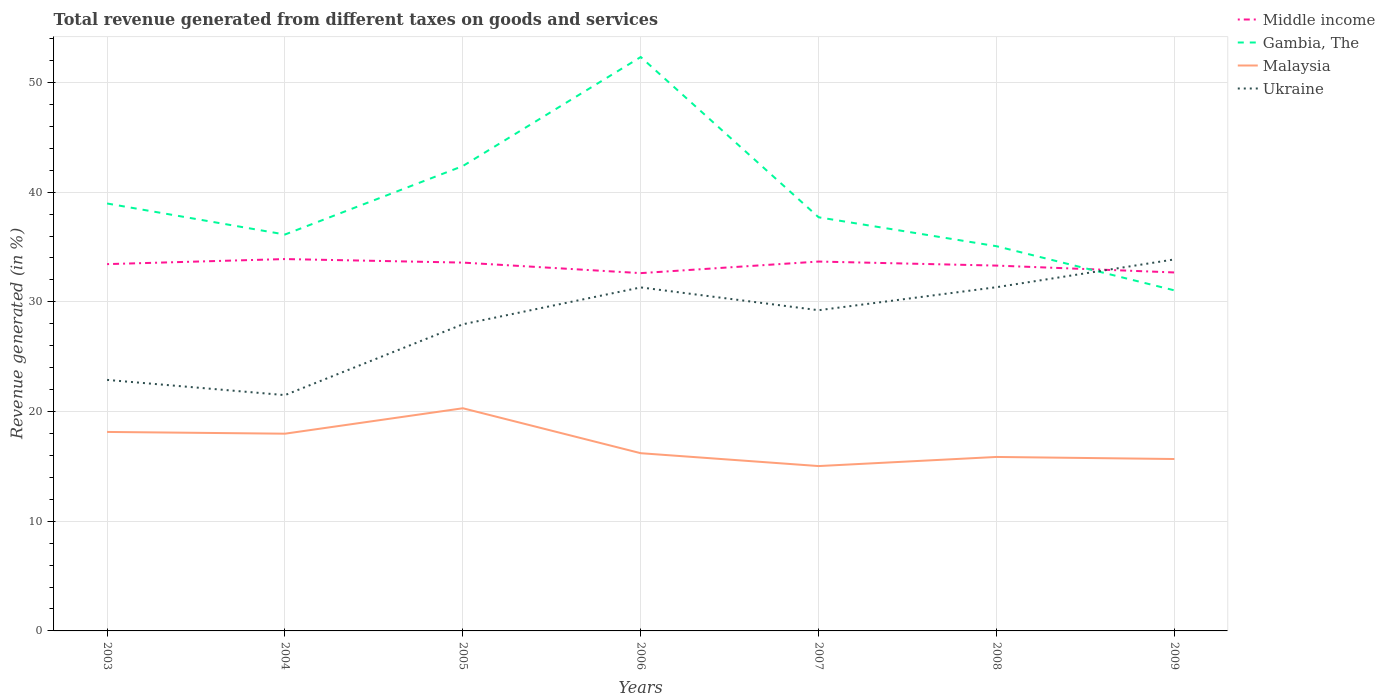Is the number of lines equal to the number of legend labels?
Make the answer very short. Yes. Across all years, what is the maximum total revenue generated in Ukraine?
Your response must be concise. 21.5. What is the total total revenue generated in Malaysia in the graph?
Provide a succinct answer. 2.12. What is the difference between the highest and the second highest total revenue generated in Middle income?
Offer a terse response. 1.28. What is the difference between the highest and the lowest total revenue generated in Malaysia?
Your answer should be compact. 3. Is the total revenue generated in Malaysia strictly greater than the total revenue generated in Middle income over the years?
Provide a succinct answer. Yes. What is the difference between two consecutive major ticks on the Y-axis?
Provide a short and direct response. 10. Are the values on the major ticks of Y-axis written in scientific E-notation?
Your answer should be very brief. No. Does the graph contain grids?
Provide a short and direct response. Yes. Where does the legend appear in the graph?
Provide a succinct answer. Top right. How many legend labels are there?
Provide a succinct answer. 4. What is the title of the graph?
Keep it short and to the point. Total revenue generated from different taxes on goods and services. Does "Iran" appear as one of the legend labels in the graph?
Provide a succinct answer. No. What is the label or title of the X-axis?
Your answer should be compact. Years. What is the label or title of the Y-axis?
Your answer should be compact. Revenue generated (in %). What is the Revenue generated (in %) in Middle income in 2003?
Make the answer very short. 33.44. What is the Revenue generated (in %) in Gambia, The in 2003?
Offer a terse response. 38.97. What is the Revenue generated (in %) in Malaysia in 2003?
Keep it short and to the point. 18.14. What is the Revenue generated (in %) in Ukraine in 2003?
Provide a succinct answer. 22.89. What is the Revenue generated (in %) in Middle income in 2004?
Give a very brief answer. 33.9. What is the Revenue generated (in %) in Gambia, The in 2004?
Your answer should be compact. 36.14. What is the Revenue generated (in %) of Malaysia in 2004?
Your answer should be compact. 17.98. What is the Revenue generated (in %) of Ukraine in 2004?
Your answer should be compact. 21.5. What is the Revenue generated (in %) of Middle income in 2005?
Your answer should be compact. 33.58. What is the Revenue generated (in %) of Gambia, The in 2005?
Your answer should be compact. 42.38. What is the Revenue generated (in %) in Malaysia in 2005?
Ensure brevity in your answer.  20.3. What is the Revenue generated (in %) of Ukraine in 2005?
Provide a short and direct response. 27.96. What is the Revenue generated (in %) in Middle income in 2006?
Keep it short and to the point. 32.62. What is the Revenue generated (in %) in Gambia, The in 2006?
Provide a short and direct response. 52.32. What is the Revenue generated (in %) of Malaysia in 2006?
Your answer should be very brief. 16.2. What is the Revenue generated (in %) of Ukraine in 2006?
Keep it short and to the point. 31.32. What is the Revenue generated (in %) of Middle income in 2007?
Your answer should be very brief. 33.68. What is the Revenue generated (in %) in Gambia, The in 2007?
Provide a succinct answer. 37.71. What is the Revenue generated (in %) in Malaysia in 2007?
Give a very brief answer. 15.03. What is the Revenue generated (in %) in Ukraine in 2007?
Make the answer very short. 29.24. What is the Revenue generated (in %) in Middle income in 2008?
Your response must be concise. 33.31. What is the Revenue generated (in %) in Gambia, The in 2008?
Provide a short and direct response. 35.07. What is the Revenue generated (in %) of Malaysia in 2008?
Ensure brevity in your answer.  15.86. What is the Revenue generated (in %) in Ukraine in 2008?
Ensure brevity in your answer.  31.34. What is the Revenue generated (in %) of Middle income in 2009?
Your answer should be compact. 32.68. What is the Revenue generated (in %) of Gambia, The in 2009?
Offer a very short reply. 31.05. What is the Revenue generated (in %) in Malaysia in 2009?
Your answer should be very brief. 15.67. What is the Revenue generated (in %) of Ukraine in 2009?
Keep it short and to the point. 33.87. Across all years, what is the maximum Revenue generated (in %) in Middle income?
Provide a succinct answer. 33.9. Across all years, what is the maximum Revenue generated (in %) of Gambia, The?
Your response must be concise. 52.32. Across all years, what is the maximum Revenue generated (in %) in Malaysia?
Provide a short and direct response. 20.3. Across all years, what is the maximum Revenue generated (in %) of Ukraine?
Offer a terse response. 33.87. Across all years, what is the minimum Revenue generated (in %) of Middle income?
Offer a terse response. 32.62. Across all years, what is the minimum Revenue generated (in %) of Gambia, The?
Keep it short and to the point. 31.05. Across all years, what is the minimum Revenue generated (in %) in Malaysia?
Your response must be concise. 15.03. Across all years, what is the minimum Revenue generated (in %) in Ukraine?
Offer a terse response. 21.5. What is the total Revenue generated (in %) of Middle income in the graph?
Ensure brevity in your answer.  233.21. What is the total Revenue generated (in %) in Gambia, The in the graph?
Ensure brevity in your answer.  273.65. What is the total Revenue generated (in %) in Malaysia in the graph?
Offer a very short reply. 119.19. What is the total Revenue generated (in %) of Ukraine in the graph?
Provide a short and direct response. 198.11. What is the difference between the Revenue generated (in %) of Middle income in 2003 and that in 2004?
Offer a terse response. -0.46. What is the difference between the Revenue generated (in %) of Gambia, The in 2003 and that in 2004?
Provide a succinct answer. 2.83. What is the difference between the Revenue generated (in %) of Malaysia in 2003 and that in 2004?
Provide a succinct answer. 0.16. What is the difference between the Revenue generated (in %) of Ukraine in 2003 and that in 2004?
Your response must be concise. 1.39. What is the difference between the Revenue generated (in %) in Middle income in 2003 and that in 2005?
Offer a terse response. -0.14. What is the difference between the Revenue generated (in %) of Gambia, The in 2003 and that in 2005?
Offer a terse response. -3.41. What is the difference between the Revenue generated (in %) of Malaysia in 2003 and that in 2005?
Give a very brief answer. -2.16. What is the difference between the Revenue generated (in %) of Ukraine in 2003 and that in 2005?
Provide a succinct answer. -5.07. What is the difference between the Revenue generated (in %) of Middle income in 2003 and that in 2006?
Your answer should be very brief. 0.82. What is the difference between the Revenue generated (in %) of Gambia, The in 2003 and that in 2006?
Your response must be concise. -13.35. What is the difference between the Revenue generated (in %) in Malaysia in 2003 and that in 2006?
Provide a succinct answer. 1.94. What is the difference between the Revenue generated (in %) of Ukraine in 2003 and that in 2006?
Provide a short and direct response. -8.43. What is the difference between the Revenue generated (in %) in Middle income in 2003 and that in 2007?
Your response must be concise. -0.23. What is the difference between the Revenue generated (in %) in Gambia, The in 2003 and that in 2007?
Your response must be concise. 1.26. What is the difference between the Revenue generated (in %) in Malaysia in 2003 and that in 2007?
Your answer should be compact. 3.11. What is the difference between the Revenue generated (in %) in Ukraine in 2003 and that in 2007?
Make the answer very short. -6.35. What is the difference between the Revenue generated (in %) of Middle income in 2003 and that in 2008?
Ensure brevity in your answer.  0.13. What is the difference between the Revenue generated (in %) in Gambia, The in 2003 and that in 2008?
Your answer should be compact. 3.9. What is the difference between the Revenue generated (in %) in Malaysia in 2003 and that in 2008?
Your response must be concise. 2.28. What is the difference between the Revenue generated (in %) of Ukraine in 2003 and that in 2008?
Provide a short and direct response. -8.45. What is the difference between the Revenue generated (in %) in Middle income in 2003 and that in 2009?
Your response must be concise. 0.76. What is the difference between the Revenue generated (in %) in Gambia, The in 2003 and that in 2009?
Give a very brief answer. 7.92. What is the difference between the Revenue generated (in %) of Malaysia in 2003 and that in 2009?
Provide a short and direct response. 2.47. What is the difference between the Revenue generated (in %) in Ukraine in 2003 and that in 2009?
Keep it short and to the point. -10.99. What is the difference between the Revenue generated (in %) in Middle income in 2004 and that in 2005?
Give a very brief answer. 0.32. What is the difference between the Revenue generated (in %) in Gambia, The in 2004 and that in 2005?
Offer a very short reply. -6.24. What is the difference between the Revenue generated (in %) in Malaysia in 2004 and that in 2005?
Offer a very short reply. -2.32. What is the difference between the Revenue generated (in %) of Ukraine in 2004 and that in 2005?
Ensure brevity in your answer.  -6.46. What is the difference between the Revenue generated (in %) of Middle income in 2004 and that in 2006?
Offer a very short reply. 1.28. What is the difference between the Revenue generated (in %) of Gambia, The in 2004 and that in 2006?
Ensure brevity in your answer.  -16.18. What is the difference between the Revenue generated (in %) of Malaysia in 2004 and that in 2006?
Your answer should be very brief. 1.78. What is the difference between the Revenue generated (in %) in Ukraine in 2004 and that in 2006?
Keep it short and to the point. -9.82. What is the difference between the Revenue generated (in %) of Middle income in 2004 and that in 2007?
Your answer should be compact. 0.23. What is the difference between the Revenue generated (in %) of Gambia, The in 2004 and that in 2007?
Your answer should be very brief. -1.57. What is the difference between the Revenue generated (in %) in Malaysia in 2004 and that in 2007?
Offer a very short reply. 2.95. What is the difference between the Revenue generated (in %) of Ukraine in 2004 and that in 2007?
Keep it short and to the point. -7.74. What is the difference between the Revenue generated (in %) of Middle income in 2004 and that in 2008?
Offer a very short reply. 0.6. What is the difference between the Revenue generated (in %) of Gambia, The in 2004 and that in 2008?
Offer a terse response. 1.07. What is the difference between the Revenue generated (in %) of Malaysia in 2004 and that in 2008?
Provide a succinct answer. 2.12. What is the difference between the Revenue generated (in %) of Ukraine in 2004 and that in 2008?
Offer a very short reply. -9.84. What is the difference between the Revenue generated (in %) in Middle income in 2004 and that in 2009?
Provide a short and direct response. 1.22. What is the difference between the Revenue generated (in %) of Gambia, The in 2004 and that in 2009?
Make the answer very short. 5.09. What is the difference between the Revenue generated (in %) of Malaysia in 2004 and that in 2009?
Keep it short and to the point. 2.31. What is the difference between the Revenue generated (in %) in Ukraine in 2004 and that in 2009?
Your answer should be compact. -12.37. What is the difference between the Revenue generated (in %) of Middle income in 2005 and that in 2006?
Offer a terse response. 0.96. What is the difference between the Revenue generated (in %) of Gambia, The in 2005 and that in 2006?
Offer a terse response. -9.94. What is the difference between the Revenue generated (in %) in Malaysia in 2005 and that in 2006?
Ensure brevity in your answer.  4.1. What is the difference between the Revenue generated (in %) in Ukraine in 2005 and that in 2006?
Make the answer very short. -3.36. What is the difference between the Revenue generated (in %) of Middle income in 2005 and that in 2007?
Your answer should be very brief. -0.1. What is the difference between the Revenue generated (in %) in Gambia, The in 2005 and that in 2007?
Your answer should be compact. 4.67. What is the difference between the Revenue generated (in %) in Malaysia in 2005 and that in 2007?
Your answer should be very brief. 5.27. What is the difference between the Revenue generated (in %) of Ukraine in 2005 and that in 2007?
Offer a terse response. -1.28. What is the difference between the Revenue generated (in %) of Middle income in 2005 and that in 2008?
Make the answer very short. 0.27. What is the difference between the Revenue generated (in %) of Gambia, The in 2005 and that in 2008?
Your answer should be very brief. 7.31. What is the difference between the Revenue generated (in %) of Malaysia in 2005 and that in 2008?
Offer a very short reply. 4.44. What is the difference between the Revenue generated (in %) of Ukraine in 2005 and that in 2008?
Your answer should be compact. -3.38. What is the difference between the Revenue generated (in %) in Middle income in 2005 and that in 2009?
Your answer should be very brief. 0.9. What is the difference between the Revenue generated (in %) in Gambia, The in 2005 and that in 2009?
Offer a terse response. 11.34. What is the difference between the Revenue generated (in %) of Malaysia in 2005 and that in 2009?
Your answer should be compact. 4.63. What is the difference between the Revenue generated (in %) in Ukraine in 2005 and that in 2009?
Ensure brevity in your answer.  -5.91. What is the difference between the Revenue generated (in %) of Middle income in 2006 and that in 2007?
Ensure brevity in your answer.  -1.06. What is the difference between the Revenue generated (in %) of Gambia, The in 2006 and that in 2007?
Keep it short and to the point. 14.61. What is the difference between the Revenue generated (in %) of Malaysia in 2006 and that in 2007?
Ensure brevity in your answer.  1.17. What is the difference between the Revenue generated (in %) in Ukraine in 2006 and that in 2007?
Provide a short and direct response. 2.08. What is the difference between the Revenue generated (in %) in Middle income in 2006 and that in 2008?
Your response must be concise. -0.69. What is the difference between the Revenue generated (in %) of Gambia, The in 2006 and that in 2008?
Provide a succinct answer. 17.25. What is the difference between the Revenue generated (in %) of Malaysia in 2006 and that in 2008?
Your response must be concise. 0.34. What is the difference between the Revenue generated (in %) in Ukraine in 2006 and that in 2008?
Offer a very short reply. -0.02. What is the difference between the Revenue generated (in %) in Middle income in 2006 and that in 2009?
Your answer should be very brief. -0.06. What is the difference between the Revenue generated (in %) in Gambia, The in 2006 and that in 2009?
Your answer should be very brief. 21.27. What is the difference between the Revenue generated (in %) in Malaysia in 2006 and that in 2009?
Offer a terse response. 0.53. What is the difference between the Revenue generated (in %) of Ukraine in 2006 and that in 2009?
Offer a terse response. -2.55. What is the difference between the Revenue generated (in %) of Middle income in 2007 and that in 2008?
Make the answer very short. 0.37. What is the difference between the Revenue generated (in %) of Gambia, The in 2007 and that in 2008?
Give a very brief answer. 2.64. What is the difference between the Revenue generated (in %) in Malaysia in 2007 and that in 2008?
Your response must be concise. -0.83. What is the difference between the Revenue generated (in %) of Ukraine in 2007 and that in 2008?
Offer a very short reply. -2.1. What is the difference between the Revenue generated (in %) of Middle income in 2007 and that in 2009?
Provide a succinct answer. 0.99. What is the difference between the Revenue generated (in %) in Gambia, The in 2007 and that in 2009?
Your answer should be very brief. 6.66. What is the difference between the Revenue generated (in %) of Malaysia in 2007 and that in 2009?
Make the answer very short. -0.64. What is the difference between the Revenue generated (in %) of Ukraine in 2007 and that in 2009?
Your answer should be very brief. -4.63. What is the difference between the Revenue generated (in %) in Middle income in 2008 and that in 2009?
Offer a terse response. 0.63. What is the difference between the Revenue generated (in %) of Gambia, The in 2008 and that in 2009?
Make the answer very short. 4.03. What is the difference between the Revenue generated (in %) in Malaysia in 2008 and that in 2009?
Offer a terse response. 0.19. What is the difference between the Revenue generated (in %) in Ukraine in 2008 and that in 2009?
Your response must be concise. -2.53. What is the difference between the Revenue generated (in %) of Middle income in 2003 and the Revenue generated (in %) of Gambia, The in 2004?
Your response must be concise. -2.7. What is the difference between the Revenue generated (in %) of Middle income in 2003 and the Revenue generated (in %) of Malaysia in 2004?
Your answer should be compact. 15.46. What is the difference between the Revenue generated (in %) of Middle income in 2003 and the Revenue generated (in %) of Ukraine in 2004?
Offer a very short reply. 11.94. What is the difference between the Revenue generated (in %) of Gambia, The in 2003 and the Revenue generated (in %) of Malaysia in 2004?
Your answer should be compact. 20.99. What is the difference between the Revenue generated (in %) of Gambia, The in 2003 and the Revenue generated (in %) of Ukraine in 2004?
Offer a terse response. 17.47. What is the difference between the Revenue generated (in %) of Malaysia in 2003 and the Revenue generated (in %) of Ukraine in 2004?
Ensure brevity in your answer.  -3.36. What is the difference between the Revenue generated (in %) in Middle income in 2003 and the Revenue generated (in %) in Gambia, The in 2005?
Your answer should be compact. -8.94. What is the difference between the Revenue generated (in %) in Middle income in 2003 and the Revenue generated (in %) in Malaysia in 2005?
Your answer should be very brief. 13.14. What is the difference between the Revenue generated (in %) of Middle income in 2003 and the Revenue generated (in %) of Ukraine in 2005?
Offer a very short reply. 5.48. What is the difference between the Revenue generated (in %) in Gambia, The in 2003 and the Revenue generated (in %) in Malaysia in 2005?
Your answer should be compact. 18.67. What is the difference between the Revenue generated (in %) in Gambia, The in 2003 and the Revenue generated (in %) in Ukraine in 2005?
Provide a short and direct response. 11.01. What is the difference between the Revenue generated (in %) of Malaysia in 2003 and the Revenue generated (in %) of Ukraine in 2005?
Provide a short and direct response. -9.82. What is the difference between the Revenue generated (in %) in Middle income in 2003 and the Revenue generated (in %) in Gambia, The in 2006?
Keep it short and to the point. -18.88. What is the difference between the Revenue generated (in %) of Middle income in 2003 and the Revenue generated (in %) of Malaysia in 2006?
Your answer should be compact. 17.24. What is the difference between the Revenue generated (in %) in Middle income in 2003 and the Revenue generated (in %) in Ukraine in 2006?
Your answer should be compact. 2.12. What is the difference between the Revenue generated (in %) of Gambia, The in 2003 and the Revenue generated (in %) of Malaysia in 2006?
Your answer should be compact. 22.77. What is the difference between the Revenue generated (in %) in Gambia, The in 2003 and the Revenue generated (in %) in Ukraine in 2006?
Keep it short and to the point. 7.65. What is the difference between the Revenue generated (in %) of Malaysia in 2003 and the Revenue generated (in %) of Ukraine in 2006?
Ensure brevity in your answer.  -13.18. What is the difference between the Revenue generated (in %) in Middle income in 2003 and the Revenue generated (in %) in Gambia, The in 2007?
Provide a short and direct response. -4.27. What is the difference between the Revenue generated (in %) of Middle income in 2003 and the Revenue generated (in %) of Malaysia in 2007?
Offer a terse response. 18.41. What is the difference between the Revenue generated (in %) in Middle income in 2003 and the Revenue generated (in %) in Ukraine in 2007?
Make the answer very short. 4.2. What is the difference between the Revenue generated (in %) in Gambia, The in 2003 and the Revenue generated (in %) in Malaysia in 2007?
Provide a succinct answer. 23.94. What is the difference between the Revenue generated (in %) in Gambia, The in 2003 and the Revenue generated (in %) in Ukraine in 2007?
Give a very brief answer. 9.73. What is the difference between the Revenue generated (in %) in Malaysia in 2003 and the Revenue generated (in %) in Ukraine in 2007?
Your answer should be very brief. -11.1. What is the difference between the Revenue generated (in %) in Middle income in 2003 and the Revenue generated (in %) in Gambia, The in 2008?
Your answer should be compact. -1.63. What is the difference between the Revenue generated (in %) of Middle income in 2003 and the Revenue generated (in %) of Malaysia in 2008?
Your answer should be compact. 17.58. What is the difference between the Revenue generated (in %) in Middle income in 2003 and the Revenue generated (in %) in Ukraine in 2008?
Give a very brief answer. 2.1. What is the difference between the Revenue generated (in %) in Gambia, The in 2003 and the Revenue generated (in %) in Malaysia in 2008?
Give a very brief answer. 23.11. What is the difference between the Revenue generated (in %) of Gambia, The in 2003 and the Revenue generated (in %) of Ukraine in 2008?
Make the answer very short. 7.63. What is the difference between the Revenue generated (in %) of Malaysia in 2003 and the Revenue generated (in %) of Ukraine in 2008?
Ensure brevity in your answer.  -13.2. What is the difference between the Revenue generated (in %) in Middle income in 2003 and the Revenue generated (in %) in Gambia, The in 2009?
Your response must be concise. 2.39. What is the difference between the Revenue generated (in %) in Middle income in 2003 and the Revenue generated (in %) in Malaysia in 2009?
Keep it short and to the point. 17.77. What is the difference between the Revenue generated (in %) of Middle income in 2003 and the Revenue generated (in %) of Ukraine in 2009?
Keep it short and to the point. -0.43. What is the difference between the Revenue generated (in %) of Gambia, The in 2003 and the Revenue generated (in %) of Malaysia in 2009?
Provide a short and direct response. 23.3. What is the difference between the Revenue generated (in %) of Gambia, The in 2003 and the Revenue generated (in %) of Ukraine in 2009?
Your answer should be compact. 5.1. What is the difference between the Revenue generated (in %) of Malaysia in 2003 and the Revenue generated (in %) of Ukraine in 2009?
Keep it short and to the point. -15.73. What is the difference between the Revenue generated (in %) of Middle income in 2004 and the Revenue generated (in %) of Gambia, The in 2005?
Provide a succinct answer. -8.48. What is the difference between the Revenue generated (in %) of Middle income in 2004 and the Revenue generated (in %) of Malaysia in 2005?
Your response must be concise. 13.6. What is the difference between the Revenue generated (in %) of Middle income in 2004 and the Revenue generated (in %) of Ukraine in 2005?
Offer a very short reply. 5.95. What is the difference between the Revenue generated (in %) of Gambia, The in 2004 and the Revenue generated (in %) of Malaysia in 2005?
Give a very brief answer. 15.84. What is the difference between the Revenue generated (in %) of Gambia, The in 2004 and the Revenue generated (in %) of Ukraine in 2005?
Provide a succinct answer. 8.18. What is the difference between the Revenue generated (in %) of Malaysia in 2004 and the Revenue generated (in %) of Ukraine in 2005?
Your answer should be very brief. -9.98. What is the difference between the Revenue generated (in %) of Middle income in 2004 and the Revenue generated (in %) of Gambia, The in 2006?
Make the answer very short. -18.42. What is the difference between the Revenue generated (in %) in Middle income in 2004 and the Revenue generated (in %) in Malaysia in 2006?
Keep it short and to the point. 17.7. What is the difference between the Revenue generated (in %) in Middle income in 2004 and the Revenue generated (in %) in Ukraine in 2006?
Offer a very short reply. 2.59. What is the difference between the Revenue generated (in %) in Gambia, The in 2004 and the Revenue generated (in %) in Malaysia in 2006?
Ensure brevity in your answer.  19.94. What is the difference between the Revenue generated (in %) in Gambia, The in 2004 and the Revenue generated (in %) in Ukraine in 2006?
Your answer should be very brief. 4.82. What is the difference between the Revenue generated (in %) in Malaysia in 2004 and the Revenue generated (in %) in Ukraine in 2006?
Give a very brief answer. -13.34. What is the difference between the Revenue generated (in %) of Middle income in 2004 and the Revenue generated (in %) of Gambia, The in 2007?
Offer a terse response. -3.81. What is the difference between the Revenue generated (in %) in Middle income in 2004 and the Revenue generated (in %) in Malaysia in 2007?
Your answer should be compact. 18.87. What is the difference between the Revenue generated (in %) of Middle income in 2004 and the Revenue generated (in %) of Ukraine in 2007?
Offer a terse response. 4.66. What is the difference between the Revenue generated (in %) in Gambia, The in 2004 and the Revenue generated (in %) in Malaysia in 2007?
Give a very brief answer. 21.11. What is the difference between the Revenue generated (in %) of Gambia, The in 2004 and the Revenue generated (in %) of Ukraine in 2007?
Offer a terse response. 6.9. What is the difference between the Revenue generated (in %) in Malaysia in 2004 and the Revenue generated (in %) in Ukraine in 2007?
Offer a very short reply. -11.26. What is the difference between the Revenue generated (in %) of Middle income in 2004 and the Revenue generated (in %) of Gambia, The in 2008?
Provide a succinct answer. -1.17. What is the difference between the Revenue generated (in %) in Middle income in 2004 and the Revenue generated (in %) in Malaysia in 2008?
Make the answer very short. 18.04. What is the difference between the Revenue generated (in %) of Middle income in 2004 and the Revenue generated (in %) of Ukraine in 2008?
Your response must be concise. 2.56. What is the difference between the Revenue generated (in %) of Gambia, The in 2004 and the Revenue generated (in %) of Malaysia in 2008?
Your answer should be very brief. 20.28. What is the difference between the Revenue generated (in %) of Gambia, The in 2004 and the Revenue generated (in %) of Ukraine in 2008?
Make the answer very short. 4.8. What is the difference between the Revenue generated (in %) of Malaysia in 2004 and the Revenue generated (in %) of Ukraine in 2008?
Give a very brief answer. -13.36. What is the difference between the Revenue generated (in %) in Middle income in 2004 and the Revenue generated (in %) in Gambia, The in 2009?
Your answer should be very brief. 2.85. What is the difference between the Revenue generated (in %) in Middle income in 2004 and the Revenue generated (in %) in Malaysia in 2009?
Ensure brevity in your answer.  18.23. What is the difference between the Revenue generated (in %) in Middle income in 2004 and the Revenue generated (in %) in Ukraine in 2009?
Make the answer very short. 0.03. What is the difference between the Revenue generated (in %) of Gambia, The in 2004 and the Revenue generated (in %) of Malaysia in 2009?
Your answer should be very brief. 20.47. What is the difference between the Revenue generated (in %) in Gambia, The in 2004 and the Revenue generated (in %) in Ukraine in 2009?
Offer a terse response. 2.27. What is the difference between the Revenue generated (in %) in Malaysia in 2004 and the Revenue generated (in %) in Ukraine in 2009?
Your answer should be compact. -15.89. What is the difference between the Revenue generated (in %) of Middle income in 2005 and the Revenue generated (in %) of Gambia, The in 2006?
Provide a succinct answer. -18.74. What is the difference between the Revenue generated (in %) in Middle income in 2005 and the Revenue generated (in %) in Malaysia in 2006?
Give a very brief answer. 17.38. What is the difference between the Revenue generated (in %) in Middle income in 2005 and the Revenue generated (in %) in Ukraine in 2006?
Provide a short and direct response. 2.26. What is the difference between the Revenue generated (in %) of Gambia, The in 2005 and the Revenue generated (in %) of Malaysia in 2006?
Offer a terse response. 26.18. What is the difference between the Revenue generated (in %) of Gambia, The in 2005 and the Revenue generated (in %) of Ukraine in 2006?
Your answer should be very brief. 11.07. What is the difference between the Revenue generated (in %) of Malaysia in 2005 and the Revenue generated (in %) of Ukraine in 2006?
Your answer should be very brief. -11.02. What is the difference between the Revenue generated (in %) in Middle income in 2005 and the Revenue generated (in %) in Gambia, The in 2007?
Keep it short and to the point. -4.13. What is the difference between the Revenue generated (in %) of Middle income in 2005 and the Revenue generated (in %) of Malaysia in 2007?
Provide a short and direct response. 18.55. What is the difference between the Revenue generated (in %) in Middle income in 2005 and the Revenue generated (in %) in Ukraine in 2007?
Offer a terse response. 4.34. What is the difference between the Revenue generated (in %) in Gambia, The in 2005 and the Revenue generated (in %) in Malaysia in 2007?
Your answer should be compact. 27.35. What is the difference between the Revenue generated (in %) in Gambia, The in 2005 and the Revenue generated (in %) in Ukraine in 2007?
Ensure brevity in your answer.  13.15. What is the difference between the Revenue generated (in %) in Malaysia in 2005 and the Revenue generated (in %) in Ukraine in 2007?
Keep it short and to the point. -8.94. What is the difference between the Revenue generated (in %) of Middle income in 2005 and the Revenue generated (in %) of Gambia, The in 2008?
Your answer should be very brief. -1.49. What is the difference between the Revenue generated (in %) of Middle income in 2005 and the Revenue generated (in %) of Malaysia in 2008?
Your answer should be compact. 17.72. What is the difference between the Revenue generated (in %) of Middle income in 2005 and the Revenue generated (in %) of Ukraine in 2008?
Provide a succinct answer. 2.24. What is the difference between the Revenue generated (in %) of Gambia, The in 2005 and the Revenue generated (in %) of Malaysia in 2008?
Make the answer very short. 26.52. What is the difference between the Revenue generated (in %) in Gambia, The in 2005 and the Revenue generated (in %) in Ukraine in 2008?
Offer a terse response. 11.05. What is the difference between the Revenue generated (in %) in Malaysia in 2005 and the Revenue generated (in %) in Ukraine in 2008?
Give a very brief answer. -11.04. What is the difference between the Revenue generated (in %) of Middle income in 2005 and the Revenue generated (in %) of Gambia, The in 2009?
Your answer should be very brief. 2.53. What is the difference between the Revenue generated (in %) in Middle income in 2005 and the Revenue generated (in %) in Malaysia in 2009?
Provide a short and direct response. 17.91. What is the difference between the Revenue generated (in %) in Middle income in 2005 and the Revenue generated (in %) in Ukraine in 2009?
Keep it short and to the point. -0.29. What is the difference between the Revenue generated (in %) of Gambia, The in 2005 and the Revenue generated (in %) of Malaysia in 2009?
Your answer should be very brief. 26.71. What is the difference between the Revenue generated (in %) of Gambia, The in 2005 and the Revenue generated (in %) of Ukraine in 2009?
Give a very brief answer. 8.51. What is the difference between the Revenue generated (in %) of Malaysia in 2005 and the Revenue generated (in %) of Ukraine in 2009?
Offer a terse response. -13.57. What is the difference between the Revenue generated (in %) in Middle income in 2006 and the Revenue generated (in %) in Gambia, The in 2007?
Give a very brief answer. -5.09. What is the difference between the Revenue generated (in %) in Middle income in 2006 and the Revenue generated (in %) in Malaysia in 2007?
Provide a short and direct response. 17.59. What is the difference between the Revenue generated (in %) in Middle income in 2006 and the Revenue generated (in %) in Ukraine in 2007?
Your answer should be very brief. 3.38. What is the difference between the Revenue generated (in %) in Gambia, The in 2006 and the Revenue generated (in %) in Malaysia in 2007?
Offer a very short reply. 37.29. What is the difference between the Revenue generated (in %) in Gambia, The in 2006 and the Revenue generated (in %) in Ukraine in 2007?
Offer a very short reply. 23.08. What is the difference between the Revenue generated (in %) of Malaysia in 2006 and the Revenue generated (in %) of Ukraine in 2007?
Your answer should be compact. -13.04. What is the difference between the Revenue generated (in %) of Middle income in 2006 and the Revenue generated (in %) of Gambia, The in 2008?
Your answer should be very brief. -2.45. What is the difference between the Revenue generated (in %) in Middle income in 2006 and the Revenue generated (in %) in Malaysia in 2008?
Provide a succinct answer. 16.76. What is the difference between the Revenue generated (in %) in Middle income in 2006 and the Revenue generated (in %) in Ukraine in 2008?
Give a very brief answer. 1.28. What is the difference between the Revenue generated (in %) of Gambia, The in 2006 and the Revenue generated (in %) of Malaysia in 2008?
Offer a terse response. 36.46. What is the difference between the Revenue generated (in %) of Gambia, The in 2006 and the Revenue generated (in %) of Ukraine in 2008?
Keep it short and to the point. 20.98. What is the difference between the Revenue generated (in %) of Malaysia in 2006 and the Revenue generated (in %) of Ukraine in 2008?
Provide a short and direct response. -15.14. What is the difference between the Revenue generated (in %) of Middle income in 2006 and the Revenue generated (in %) of Gambia, The in 2009?
Make the answer very short. 1.57. What is the difference between the Revenue generated (in %) in Middle income in 2006 and the Revenue generated (in %) in Malaysia in 2009?
Offer a terse response. 16.95. What is the difference between the Revenue generated (in %) in Middle income in 2006 and the Revenue generated (in %) in Ukraine in 2009?
Provide a succinct answer. -1.25. What is the difference between the Revenue generated (in %) in Gambia, The in 2006 and the Revenue generated (in %) in Malaysia in 2009?
Offer a very short reply. 36.65. What is the difference between the Revenue generated (in %) of Gambia, The in 2006 and the Revenue generated (in %) of Ukraine in 2009?
Your response must be concise. 18.45. What is the difference between the Revenue generated (in %) of Malaysia in 2006 and the Revenue generated (in %) of Ukraine in 2009?
Your answer should be compact. -17.67. What is the difference between the Revenue generated (in %) in Middle income in 2007 and the Revenue generated (in %) in Gambia, The in 2008?
Offer a terse response. -1.4. What is the difference between the Revenue generated (in %) in Middle income in 2007 and the Revenue generated (in %) in Malaysia in 2008?
Your answer should be very brief. 17.81. What is the difference between the Revenue generated (in %) of Middle income in 2007 and the Revenue generated (in %) of Ukraine in 2008?
Offer a very short reply. 2.34. What is the difference between the Revenue generated (in %) in Gambia, The in 2007 and the Revenue generated (in %) in Malaysia in 2008?
Keep it short and to the point. 21.85. What is the difference between the Revenue generated (in %) in Gambia, The in 2007 and the Revenue generated (in %) in Ukraine in 2008?
Give a very brief answer. 6.37. What is the difference between the Revenue generated (in %) in Malaysia in 2007 and the Revenue generated (in %) in Ukraine in 2008?
Your answer should be compact. -16.31. What is the difference between the Revenue generated (in %) in Middle income in 2007 and the Revenue generated (in %) in Gambia, The in 2009?
Provide a succinct answer. 2.63. What is the difference between the Revenue generated (in %) of Middle income in 2007 and the Revenue generated (in %) of Malaysia in 2009?
Offer a very short reply. 18. What is the difference between the Revenue generated (in %) of Middle income in 2007 and the Revenue generated (in %) of Ukraine in 2009?
Offer a very short reply. -0.2. What is the difference between the Revenue generated (in %) of Gambia, The in 2007 and the Revenue generated (in %) of Malaysia in 2009?
Give a very brief answer. 22.04. What is the difference between the Revenue generated (in %) in Gambia, The in 2007 and the Revenue generated (in %) in Ukraine in 2009?
Provide a short and direct response. 3.84. What is the difference between the Revenue generated (in %) in Malaysia in 2007 and the Revenue generated (in %) in Ukraine in 2009?
Make the answer very short. -18.84. What is the difference between the Revenue generated (in %) in Middle income in 2008 and the Revenue generated (in %) in Gambia, The in 2009?
Your answer should be very brief. 2.26. What is the difference between the Revenue generated (in %) in Middle income in 2008 and the Revenue generated (in %) in Malaysia in 2009?
Provide a short and direct response. 17.63. What is the difference between the Revenue generated (in %) in Middle income in 2008 and the Revenue generated (in %) in Ukraine in 2009?
Your answer should be compact. -0.56. What is the difference between the Revenue generated (in %) in Gambia, The in 2008 and the Revenue generated (in %) in Malaysia in 2009?
Provide a short and direct response. 19.4. What is the difference between the Revenue generated (in %) of Gambia, The in 2008 and the Revenue generated (in %) of Ukraine in 2009?
Your answer should be compact. 1.2. What is the difference between the Revenue generated (in %) of Malaysia in 2008 and the Revenue generated (in %) of Ukraine in 2009?
Your answer should be compact. -18.01. What is the average Revenue generated (in %) in Middle income per year?
Your answer should be compact. 33.32. What is the average Revenue generated (in %) in Gambia, The per year?
Give a very brief answer. 39.09. What is the average Revenue generated (in %) of Malaysia per year?
Your answer should be very brief. 17.03. What is the average Revenue generated (in %) of Ukraine per year?
Offer a very short reply. 28.3. In the year 2003, what is the difference between the Revenue generated (in %) in Middle income and Revenue generated (in %) in Gambia, The?
Your answer should be compact. -5.53. In the year 2003, what is the difference between the Revenue generated (in %) in Middle income and Revenue generated (in %) in Malaysia?
Ensure brevity in your answer.  15.3. In the year 2003, what is the difference between the Revenue generated (in %) in Middle income and Revenue generated (in %) in Ukraine?
Make the answer very short. 10.56. In the year 2003, what is the difference between the Revenue generated (in %) in Gambia, The and Revenue generated (in %) in Malaysia?
Make the answer very short. 20.83. In the year 2003, what is the difference between the Revenue generated (in %) in Gambia, The and Revenue generated (in %) in Ukraine?
Give a very brief answer. 16.08. In the year 2003, what is the difference between the Revenue generated (in %) of Malaysia and Revenue generated (in %) of Ukraine?
Your answer should be very brief. -4.74. In the year 2004, what is the difference between the Revenue generated (in %) in Middle income and Revenue generated (in %) in Gambia, The?
Your response must be concise. -2.24. In the year 2004, what is the difference between the Revenue generated (in %) in Middle income and Revenue generated (in %) in Malaysia?
Provide a short and direct response. 15.92. In the year 2004, what is the difference between the Revenue generated (in %) in Middle income and Revenue generated (in %) in Ukraine?
Your response must be concise. 12.4. In the year 2004, what is the difference between the Revenue generated (in %) in Gambia, The and Revenue generated (in %) in Malaysia?
Offer a very short reply. 18.16. In the year 2004, what is the difference between the Revenue generated (in %) of Gambia, The and Revenue generated (in %) of Ukraine?
Your answer should be compact. 14.64. In the year 2004, what is the difference between the Revenue generated (in %) of Malaysia and Revenue generated (in %) of Ukraine?
Keep it short and to the point. -3.52. In the year 2005, what is the difference between the Revenue generated (in %) in Middle income and Revenue generated (in %) in Gambia, The?
Your answer should be very brief. -8.8. In the year 2005, what is the difference between the Revenue generated (in %) in Middle income and Revenue generated (in %) in Malaysia?
Your answer should be very brief. 13.28. In the year 2005, what is the difference between the Revenue generated (in %) in Middle income and Revenue generated (in %) in Ukraine?
Your answer should be very brief. 5.62. In the year 2005, what is the difference between the Revenue generated (in %) of Gambia, The and Revenue generated (in %) of Malaysia?
Your answer should be compact. 22.08. In the year 2005, what is the difference between the Revenue generated (in %) of Gambia, The and Revenue generated (in %) of Ukraine?
Ensure brevity in your answer.  14.43. In the year 2005, what is the difference between the Revenue generated (in %) in Malaysia and Revenue generated (in %) in Ukraine?
Offer a very short reply. -7.66. In the year 2006, what is the difference between the Revenue generated (in %) of Middle income and Revenue generated (in %) of Gambia, The?
Give a very brief answer. -19.7. In the year 2006, what is the difference between the Revenue generated (in %) in Middle income and Revenue generated (in %) in Malaysia?
Your answer should be very brief. 16.42. In the year 2006, what is the difference between the Revenue generated (in %) of Middle income and Revenue generated (in %) of Ukraine?
Your answer should be very brief. 1.3. In the year 2006, what is the difference between the Revenue generated (in %) of Gambia, The and Revenue generated (in %) of Malaysia?
Keep it short and to the point. 36.12. In the year 2006, what is the difference between the Revenue generated (in %) in Gambia, The and Revenue generated (in %) in Ukraine?
Offer a terse response. 21. In the year 2006, what is the difference between the Revenue generated (in %) of Malaysia and Revenue generated (in %) of Ukraine?
Your response must be concise. -15.11. In the year 2007, what is the difference between the Revenue generated (in %) of Middle income and Revenue generated (in %) of Gambia, The?
Offer a terse response. -4.03. In the year 2007, what is the difference between the Revenue generated (in %) in Middle income and Revenue generated (in %) in Malaysia?
Provide a succinct answer. 18.64. In the year 2007, what is the difference between the Revenue generated (in %) in Middle income and Revenue generated (in %) in Ukraine?
Offer a very short reply. 4.44. In the year 2007, what is the difference between the Revenue generated (in %) in Gambia, The and Revenue generated (in %) in Malaysia?
Your response must be concise. 22.68. In the year 2007, what is the difference between the Revenue generated (in %) of Gambia, The and Revenue generated (in %) of Ukraine?
Offer a very short reply. 8.47. In the year 2007, what is the difference between the Revenue generated (in %) of Malaysia and Revenue generated (in %) of Ukraine?
Give a very brief answer. -14.21. In the year 2008, what is the difference between the Revenue generated (in %) of Middle income and Revenue generated (in %) of Gambia, The?
Give a very brief answer. -1.77. In the year 2008, what is the difference between the Revenue generated (in %) in Middle income and Revenue generated (in %) in Malaysia?
Provide a short and direct response. 17.45. In the year 2008, what is the difference between the Revenue generated (in %) of Middle income and Revenue generated (in %) of Ukraine?
Your response must be concise. 1.97. In the year 2008, what is the difference between the Revenue generated (in %) in Gambia, The and Revenue generated (in %) in Malaysia?
Provide a short and direct response. 19.21. In the year 2008, what is the difference between the Revenue generated (in %) in Gambia, The and Revenue generated (in %) in Ukraine?
Your answer should be compact. 3.74. In the year 2008, what is the difference between the Revenue generated (in %) of Malaysia and Revenue generated (in %) of Ukraine?
Ensure brevity in your answer.  -15.48. In the year 2009, what is the difference between the Revenue generated (in %) in Middle income and Revenue generated (in %) in Gambia, The?
Ensure brevity in your answer.  1.63. In the year 2009, what is the difference between the Revenue generated (in %) of Middle income and Revenue generated (in %) of Malaysia?
Your answer should be very brief. 17.01. In the year 2009, what is the difference between the Revenue generated (in %) of Middle income and Revenue generated (in %) of Ukraine?
Provide a short and direct response. -1.19. In the year 2009, what is the difference between the Revenue generated (in %) in Gambia, The and Revenue generated (in %) in Malaysia?
Provide a short and direct response. 15.38. In the year 2009, what is the difference between the Revenue generated (in %) in Gambia, The and Revenue generated (in %) in Ukraine?
Offer a terse response. -2.82. In the year 2009, what is the difference between the Revenue generated (in %) in Malaysia and Revenue generated (in %) in Ukraine?
Your answer should be compact. -18.2. What is the ratio of the Revenue generated (in %) in Middle income in 2003 to that in 2004?
Your response must be concise. 0.99. What is the ratio of the Revenue generated (in %) of Gambia, The in 2003 to that in 2004?
Provide a succinct answer. 1.08. What is the ratio of the Revenue generated (in %) of Malaysia in 2003 to that in 2004?
Give a very brief answer. 1.01. What is the ratio of the Revenue generated (in %) of Ukraine in 2003 to that in 2004?
Your answer should be very brief. 1.06. What is the ratio of the Revenue generated (in %) in Gambia, The in 2003 to that in 2005?
Offer a terse response. 0.92. What is the ratio of the Revenue generated (in %) in Malaysia in 2003 to that in 2005?
Provide a short and direct response. 0.89. What is the ratio of the Revenue generated (in %) in Ukraine in 2003 to that in 2005?
Provide a short and direct response. 0.82. What is the ratio of the Revenue generated (in %) in Middle income in 2003 to that in 2006?
Offer a very short reply. 1.03. What is the ratio of the Revenue generated (in %) of Gambia, The in 2003 to that in 2006?
Give a very brief answer. 0.74. What is the ratio of the Revenue generated (in %) in Malaysia in 2003 to that in 2006?
Ensure brevity in your answer.  1.12. What is the ratio of the Revenue generated (in %) in Ukraine in 2003 to that in 2006?
Provide a short and direct response. 0.73. What is the ratio of the Revenue generated (in %) in Middle income in 2003 to that in 2007?
Provide a succinct answer. 0.99. What is the ratio of the Revenue generated (in %) of Gambia, The in 2003 to that in 2007?
Offer a very short reply. 1.03. What is the ratio of the Revenue generated (in %) in Malaysia in 2003 to that in 2007?
Your answer should be very brief. 1.21. What is the ratio of the Revenue generated (in %) of Ukraine in 2003 to that in 2007?
Offer a very short reply. 0.78. What is the ratio of the Revenue generated (in %) of Middle income in 2003 to that in 2008?
Give a very brief answer. 1. What is the ratio of the Revenue generated (in %) in Malaysia in 2003 to that in 2008?
Offer a terse response. 1.14. What is the ratio of the Revenue generated (in %) of Ukraine in 2003 to that in 2008?
Your answer should be very brief. 0.73. What is the ratio of the Revenue generated (in %) in Middle income in 2003 to that in 2009?
Keep it short and to the point. 1.02. What is the ratio of the Revenue generated (in %) in Gambia, The in 2003 to that in 2009?
Provide a succinct answer. 1.26. What is the ratio of the Revenue generated (in %) in Malaysia in 2003 to that in 2009?
Offer a terse response. 1.16. What is the ratio of the Revenue generated (in %) of Ukraine in 2003 to that in 2009?
Your response must be concise. 0.68. What is the ratio of the Revenue generated (in %) of Middle income in 2004 to that in 2005?
Offer a terse response. 1.01. What is the ratio of the Revenue generated (in %) of Gambia, The in 2004 to that in 2005?
Provide a succinct answer. 0.85. What is the ratio of the Revenue generated (in %) in Malaysia in 2004 to that in 2005?
Your response must be concise. 0.89. What is the ratio of the Revenue generated (in %) in Ukraine in 2004 to that in 2005?
Your response must be concise. 0.77. What is the ratio of the Revenue generated (in %) of Middle income in 2004 to that in 2006?
Provide a succinct answer. 1.04. What is the ratio of the Revenue generated (in %) in Gambia, The in 2004 to that in 2006?
Keep it short and to the point. 0.69. What is the ratio of the Revenue generated (in %) in Malaysia in 2004 to that in 2006?
Give a very brief answer. 1.11. What is the ratio of the Revenue generated (in %) of Ukraine in 2004 to that in 2006?
Your answer should be very brief. 0.69. What is the ratio of the Revenue generated (in %) of Gambia, The in 2004 to that in 2007?
Give a very brief answer. 0.96. What is the ratio of the Revenue generated (in %) of Malaysia in 2004 to that in 2007?
Offer a very short reply. 1.2. What is the ratio of the Revenue generated (in %) in Ukraine in 2004 to that in 2007?
Keep it short and to the point. 0.74. What is the ratio of the Revenue generated (in %) in Middle income in 2004 to that in 2008?
Make the answer very short. 1.02. What is the ratio of the Revenue generated (in %) of Gambia, The in 2004 to that in 2008?
Provide a short and direct response. 1.03. What is the ratio of the Revenue generated (in %) of Malaysia in 2004 to that in 2008?
Provide a short and direct response. 1.13. What is the ratio of the Revenue generated (in %) of Ukraine in 2004 to that in 2008?
Your answer should be very brief. 0.69. What is the ratio of the Revenue generated (in %) of Middle income in 2004 to that in 2009?
Keep it short and to the point. 1.04. What is the ratio of the Revenue generated (in %) of Gambia, The in 2004 to that in 2009?
Provide a short and direct response. 1.16. What is the ratio of the Revenue generated (in %) in Malaysia in 2004 to that in 2009?
Offer a very short reply. 1.15. What is the ratio of the Revenue generated (in %) in Ukraine in 2004 to that in 2009?
Your answer should be compact. 0.63. What is the ratio of the Revenue generated (in %) in Middle income in 2005 to that in 2006?
Your answer should be very brief. 1.03. What is the ratio of the Revenue generated (in %) in Gambia, The in 2005 to that in 2006?
Your response must be concise. 0.81. What is the ratio of the Revenue generated (in %) in Malaysia in 2005 to that in 2006?
Your response must be concise. 1.25. What is the ratio of the Revenue generated (in %) of Ukraine in 2005 to that in 2006?
Your answer should be compact. 0.89. What is the ratio of the Revenue generated (in %) in Gambia, The in 2005 to that in 2007?
Keep it short and to the point. 1.12. What is the ratio of the Revenue generated (in %) of Malaysia in 2005 to that in 2007?
Your response must be concise. 1.35. What is the ratio of the Revenue generated (in %) in Ukraine in 2005 to that in 2007?
Your response must be concise. 0.96. What is the ratio of the Revenue generated (in %) of Middle income in 2005 to that in 2008?
Make the answer very short. 1.01. What is the ratio of the Revenue generated (in %) of Gambia, The in 2005 to that in 2008?
Your response must be concise. 1.21. What is the ratio of the Revenue generated (in %) of Malaysia in 2005 to that in 2008?
Give a very brief answer. 1.28. What is the ratio of the Revenue generated (in %) in Ukraine in 2005 to that in 2008?
Offer a very short reply. 0.89. What is the ratio of the Revenue generated (in %) of Middle income in 2005 to that in 2009?
Your answer should be very brief. 1.03. What is the ratio of the Revenue generated (in %) of Gambia, The in 2005 to that in 2009?
Ensure brevity in your answer.  1.37. What is the ratio of the Revenue generated (in %) in Malaysia in 2005 to that in 2009?
Offer a terse response. 1.3. What is the ratio of the Revenue generated (in %) of Ukraine in 2005 to that in 2009?
Provide a succinct answer. 0.83. What is the ratio of the Revenue generated (in %) of Middle income in 2006 to that in 2007?
Provide a short and direct response. 0.97. What is the ratio of the Revenue generated (in %) of Gambia, The in 2006 to that in 2007?
Offer a very short reply. 1.39. What is the ratio of the Revenue generated (in %) of Malaysia in 2006 to that in 2007?
Make the answer very short. 1.08. What is the ratio of the Revenue generated (in %) of Ukraine in 2006 to that in 2007?
Make the answer very short. 1.07. What is the ratio of the Revenue generated (in %) in Middle income in 2006 to that in 2008?
Keep it short and to the point. 0.98. What is the ratio of the Revenue generated (in %) of Gambia, The in 2006 to that in 2008?
Provide a short and direct response. 1.49. What is the ratio of the Revenue generated (in %) of Malaysia in 2006 to that in 2008?
Ensure brevity in your answer.  1.02. What is the ratio of the Revenue generated (in %) in Ukraine in 2006 to that in 2008?
Give a very brief answer. 1. What is the ratio of the Revenue generated (in %) in Middle income in 2006 to that in 2009?
Your response must be concise. 1. What is the ratio of the Revenue generated (in %) of Gambia, The in 2006 to that in 2009?
Offer a very short reply. 1.69. What is the ratio of the Revenue generated (in %) of Malaysia in 2006 to that in 2009?
Make the answer very short. 1.03. What is the ratio of the Revenue generated (in %) of Ukraine in 2006 to that in 2009?
Your answer should be compact. 0.92. What is the ratio of the Revenue generated (in %) in Middle income in 2007 to that in 2008?
Offer a terse response. 1.01. What is the ratio of the Revenue generated (in %) in Gambia, The in 2007 to that in 2008?
Ensure brevity in your answer.  1.08. What is the ratio of the Revenue generated (in %) in Malaysia in 2007 to that in 2008?
Provide a succinct answer. 0.95. What is the ratio of the Revenue generated (in %) in Ukraine in 2007 to that in 2008?
Keep it short and to the point. 0.93. What is the ratio of the Revenue generated (in %) in Middle income in 2007 to that in 2009?
Provide a short and direct response. 1.03. What is the ratio of the Revenue generated (in %) of Gambia, The in 2007 to that in 2009?
Your response must be concise. 1.21. What is the ratio of the Revenue generated (in %) in Malaysia in 2007 to that in 2009?
Your answer should be very brief. 0.96. What is the ratio of the Revenue generated (in %) in Ukraine in 2007 to that in 2009?
Provide a short and direct response. 0.86. What is the ratio of the Revenue generated (in %) of Middle income in 2008 to that in 2009?
Offer a terse response. 1.02. What is the ratio of the Revenue generated (in %) of Gambia, The in 2008 to that in 2009?
Your response must be concise. 1.13. What is the ratio of the Revenue generated (in %) in Malaysia in 2008 to that in 2009?
Ensure brevity in your answer.  1.01. What is the ratio of the Revenue generated (in %) in Ukraine in 2008 to that in 2009?
Your answer should be very brief. 0.93. What is the difference between the highest and the second highest Revenue generated (in %) in Middle income?
Your answer should be very brief. 0.23. What is the difference between the highest and the second highest Revenue generated (in %) of Gambia, The?
Ensure brevity in your answer.  9.94. What is the difference between the highest and the second highest Revenue generated (in %) of Malaysia?
Ensure brevity in your answer.  2.16. What is the difference between the highest and the second highest Revenue generated (in %) of Ukraine?
Ensure brevity in your answer.  2.53. What is the difference between the highest and the lowest Revenue generated (in %) in Middle income?
Provide a short and direct response. 1.28. What is the difference between the highest and the lowest Revenue generated (in %) in Gambia, The?
Offer a terse response. 21.27. What is the difference between the highest and the lowest Revenue generated (in %) in Malaysia?
Make the answer very short. 5.27. What is the difference between the highest and the lowest Revenue generated (in %) in Ukraine?
Offer a very short reply. 12.37. 